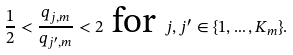Convert formula to latex. <formula><loc_0><loc_0><loc_500><loc_500>\frac { 1 } 2 < \frac { q _ { j , m } } { q _ { j ^ { \prime } , m } } < 2 \text { for } j , j ^ { \prime } \in \{ 1 , \dots , K _ { m } \} .</formula> 